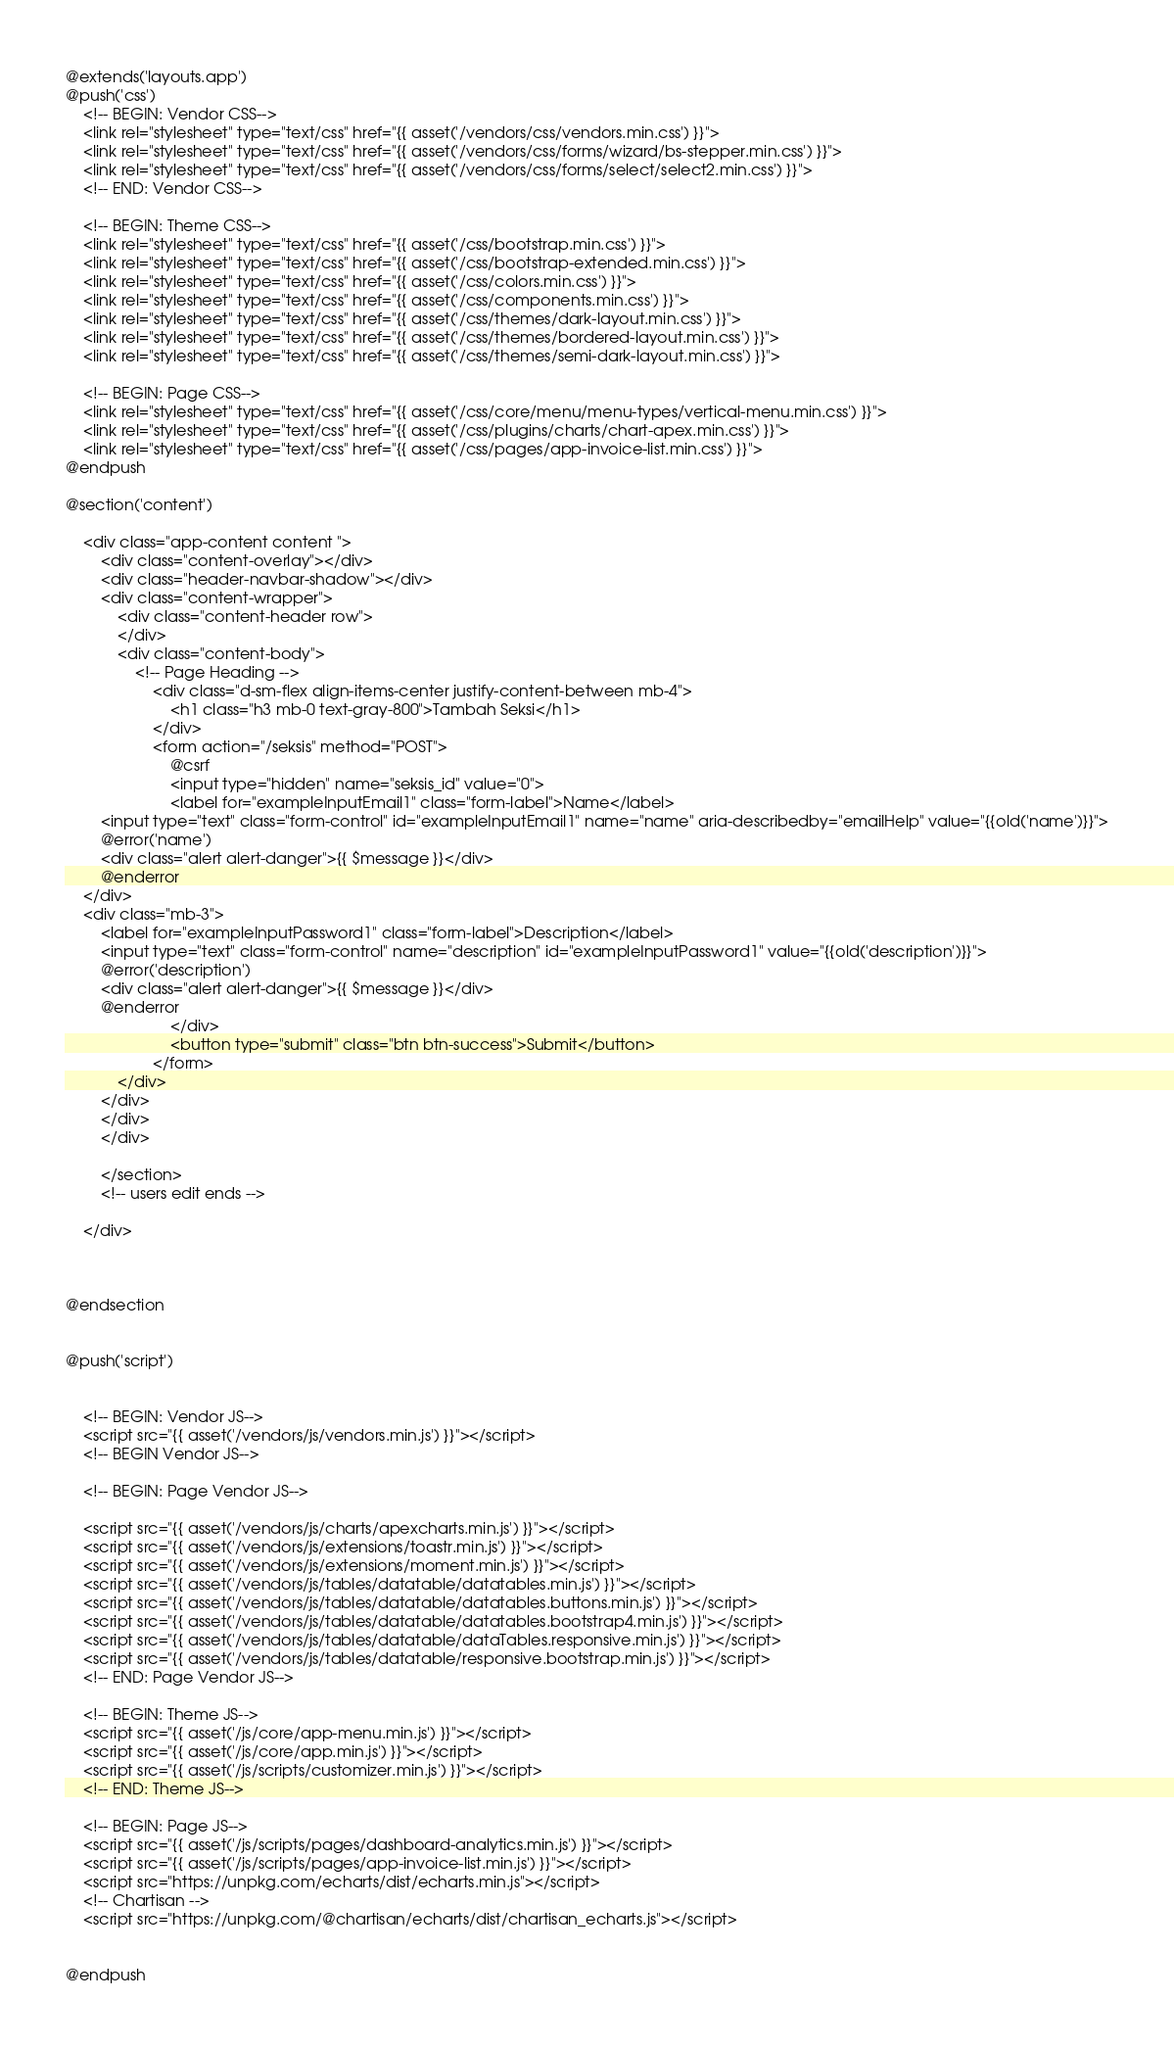<code> <loc_0><loc_0><loc_500><loc_500><_PHP_>@extends('layouts.app')
@push('css')
    <!-- BEGIN: Vendor CSS-->
    <link rel="stylesheet" type="text/css" href="{{ asset('/vendors/css/vendors.min.css') }}">
    <link rel="stylesheet" type="text/css" href="{{ asset('/vendors/css/forms/wizard/bs-stepper.min.css') }}">
    <link rel="stylesheet" type="text/css" href="{{ asset('/vendors/css/forms/select/select2.min.css') }}">
    <!-- END: Vendor CSS-->

    <!-- BEGIN: Theme CSS-->
    <link rel="stylesheet" type="text/css" href="{{ asset('/css/bootstrap.min.css') }}">
    <link rel="stylesheet" type="text/css" href="{{ asset('/css/bootstrap-extended.min.css') }}">
    <link rel="stylesheet" type="text/css" href="{{ asset('/css/colors.min.css') }}">
    <link rel="stylesheet" type="text/css" href="{{ asset('/css/components.min.css') }}">
    <link rel="stylesheet" type="text/css" href="{{ asset('/css/themes/dark-layout.min.css') }}">
    <link rel="stylesheet" type="text/css" href="{{ asset('/css/themes/bordered-layout.min.css') }}">
    <link rel="stylesheet" type="text/css" href="{{ asset('/css/themes/semi-dark-layout.min.css') }}">

    <!-- BEGIN: Page CSS-->
    <link rel="stylesheet" type="text/css" href="{{ asset('/css/core/menu/menu-types/vertical-menu.min.css') }}">
    <link rel="stylesheet" type="text/css" href="{{ asset('/css/plugins/charts/chart-apex.min.css') }}">
    <link rel="stylesheet" type="text/css" href="{{ asset('/css/pages/app-invoice-list.min.css') }}">
@endpush

@section('content')

    <div class="app-content content ">
        <div class="content-overlay"></div>
        <div class="header-navbar-shadow"></div>
        <div class="content-wrapper">
            <div class="content-header row">
            </div>
            <div class="content-body">
                <!-- Page Heading -->
                    <div class="d-sm-flex align-items-center justify-content-between mb-4">
                        <h1 class="h3 mb-0 text-gray-800">Tambah Seksi</h1>
                    </div>
                    <form action="/seksis" method="POST">
                        @csrf
                        <input type="hidden" name="seksis_id" value="0">
                        <label for="exampleInputEmail1" class="form-label">Name</label>
        <input type="text" class="form-control" id="exampleInputEmail1" name="name" aria-describedby="emailHelp" value="{{old('name')}}">
        @error('name')
        <div class="alert alert-danger">{{ $message }}</div>
        @enderror
    </div>
    <div class="mb-3">
        <label for="exampleInputPassword1" class="form-label">Description</label>
        <input type="text" class="form-control" name="description" id="exampleInputPassword1" value="{{old('description')}}">
        @error('description')
        <div class="alert alert-danger">{{ $message }}</div>
        @enderror
                        </div>
                        <button type="submit" class="btn btn-success">Submit</button>
                    </form>
            </div>
        </div>
        </div>
        </div>

        </section>
        <!-- users edit ends -->

    </div>



@endsection


@push('script')


    <!-- BEGIN: Vendor JS-->
    <script src="{{ asset('/vendors/js/vendors.min.js') }}"></script>
    <!-- BEGIN Vendor JS-->

    <!-- BEGIN: Page Vendor JS-->

    <script src="{{ asset('/vendors/js/charts/apexcharts.min.js') }}"></script>
    <script src="{{ asset('/vendors/js/extensions/toastr.min.js') }}"></script>
    <script src="{{ asset('/vendors/js/extensions/moment.min.js') }}"></script>
    <script src="{{ asset('/vendors/js/tables/datatable/datatables.min.js') }}"></script>
    <script src="{{ asset('/vendors/js/tables/datatable/datatables.buttons.min.js') }}"></script>
    <script src="{{ asset('/vendors/js/tables/datatable/datatables.bootstrap4.min.js') }}"></script>
    <script src="{{ asset('/vendors/js/tables/datatable/dataTables.responsive.min.js') }}"></script>
    <script src="{{ asset('/vendors/js/tables/datatable/responsive.bootstrap.min.js') }}"></script>
    <!-- END: Page Vendor JS-->

    <!-- BEGIN: Theme JS-->
    <script src="{{ asset('/js/core/app-menu.min.js') }}"></script>
    <script src="{{ asset('/js/core/app.min.js') }}"></script>
    <script src="{{ asset('/js/scripts/customizer.min.js') }}"></script>
    <!-- END: Theme JS-->

    <!-- BEGIN: Page JS-->
    <script src="{{ asset('/js/scripts/pages/dashboard-analytics.min.js') }}"></script>
    <script src="{{ asset('/js/scripts/pages/app-invoice-list.min.js') }}"></script>
    <script src="https://unpkg.com/echarts/dist/echarts.min.js"></script>
    <!-- Chartisan -->
    <script src="https://unpkg.com/@chartisan/echarts/dist/chartisan_echarts.js"></script>


@endpush
</code> 